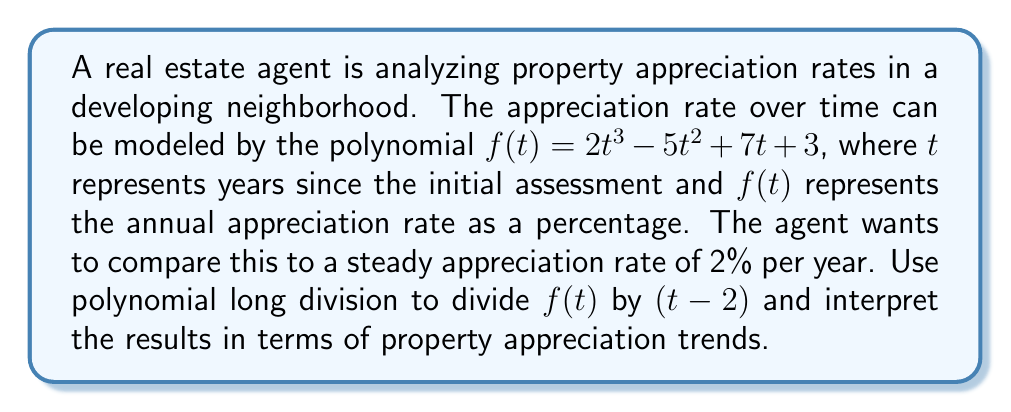Teach me how to tackle this problem. Let's perform polynomial long division of $f(t) = 2t^3 - 5t^2 + 7t + 3$ by $(t - 2)$:

$$\begin{array}{r}
2t^2 + 4t + 15 \\
t - 2 \enclose{longdiv}{2t^3 - 5t^2 + 7t + 3} \\
\underline{2t^3 - 4t^2} \\
-t^2 + 7t \\
\underline{-t^2 + 2t} \\
5t + 3 \\
\underline{5t - 10} \\
13
\end{array}$$

The result of the division is:
$f(t) = (t - 2)(2t^2 + 4t + 15) + 13$

Interpreting this result:

1. The quotient $2t^2 + 4t + 15$ represents the trend of the appreciation rate compared to the steady 2% rate:
   - The $2t^2$ term indicates an accelerating appreciation over time.
   - The $4t$ term suggests a linear increase in appreciation.
   - The constant 15 implies a base appreciation rate above the 2% benchmark.

2. The remainder 13 means that when $t = 2$ (i.e., 2 years after the initial assessment), the appreciation rate will be 13 percentage points higher than the steady 2% rate, or 15% total.

3. The factor $(t - 2)$ indicates that at $t = 2$ years, there's a significant change in the appreciation trend, possibly due to neighborhood developments or market shifts.

This analysis suggests that properties in this neighborhood are appreciating at a rate that not only exceeds the steady 2% benchmark but also accelerates over time, making it an potentially lucrative investment opportunity for clients looking for high appreciation potential.
Answer: The polynomial division results in $f(t) = (t - 2)(2t^2 + 4t + 15) + 13$, indicating an accelerating appreciation rate that exceeds the 2% benchmark by 13 percentage points after 2 years, with continued growth potential thereafter. 